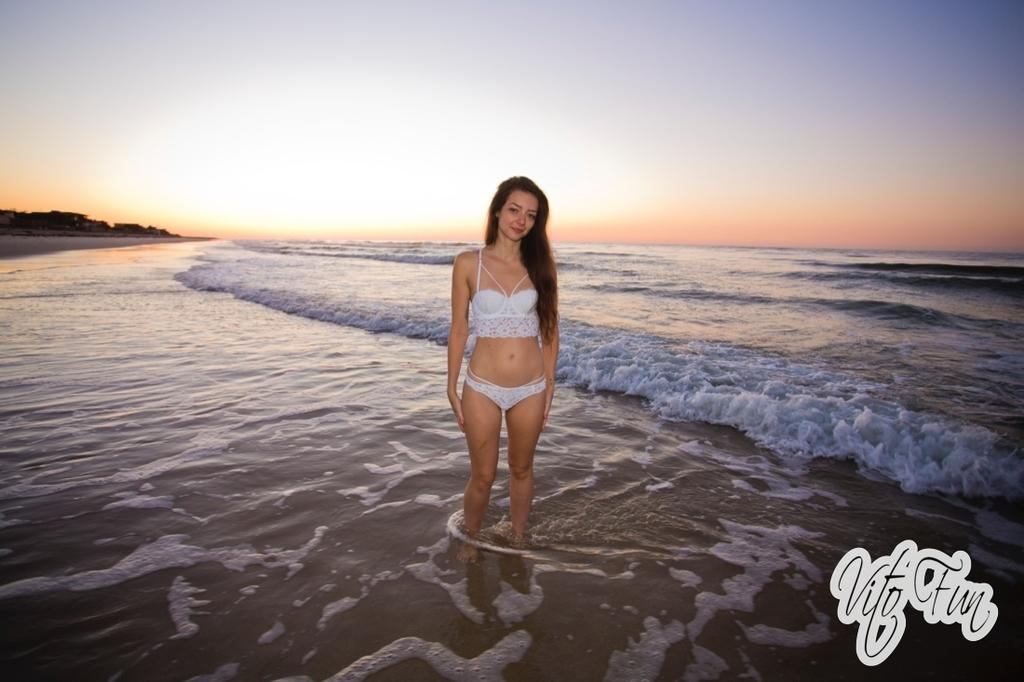What is the woman in the image doing? The woman is standing in the sea. What can be seen in the distance behind the woman? There are buildings visible in the distance. What is visible in the background of the image? The sky is visible in the background of the image. What type of test can be seen being conducted in the image? There is no test being conducted in the image; it features a woman standing in the sea with buildings in the distance and the sky visible in the background. 